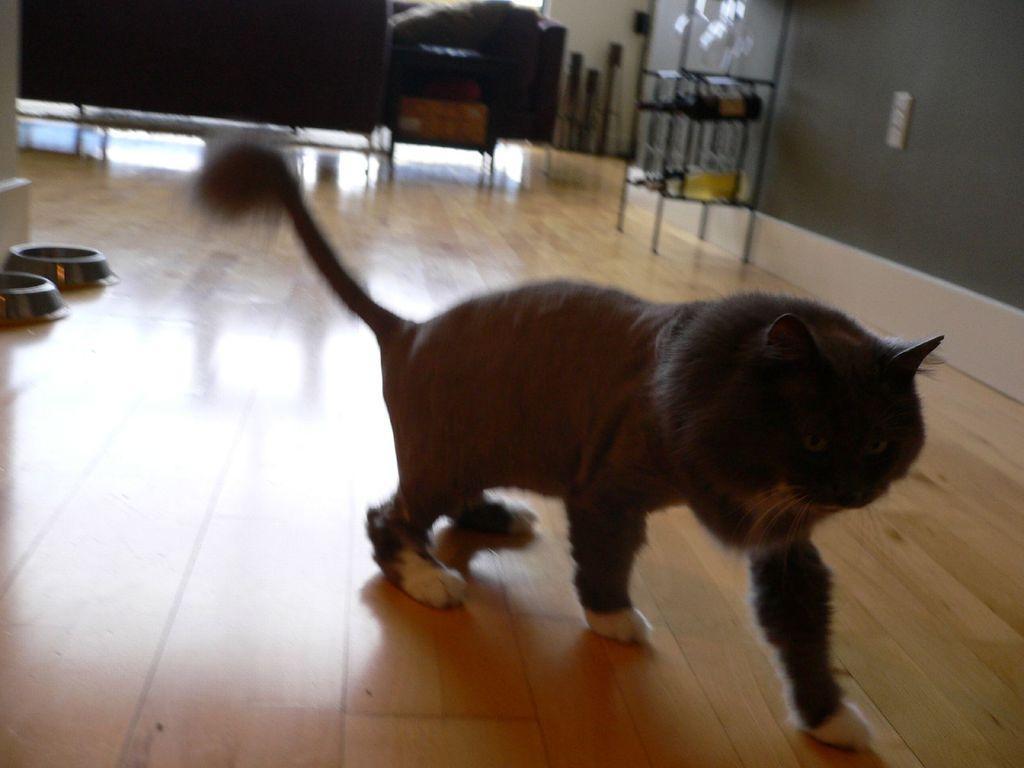How would you summarize this image in a sentence or two? In this picture I can see a cat, there are pet feeding bowls, there are wine bottles in a rack, and in the background there are some objects. 